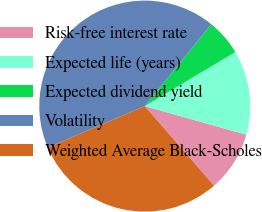<chart> <loc_0><loc_0><loc_500><loc_500><pie_chart><fcel>Risk-free interest rate<fcel>Expected life (years)<fcel>Expected dividend yield<fcel>Volatility<fcel>Weighted Average Black-Scholes<nl><fcel>9.24%<fcel>12.92%<fcel>5.57%<fcel>42.3%<fcel>29.97%<nl></chart> 